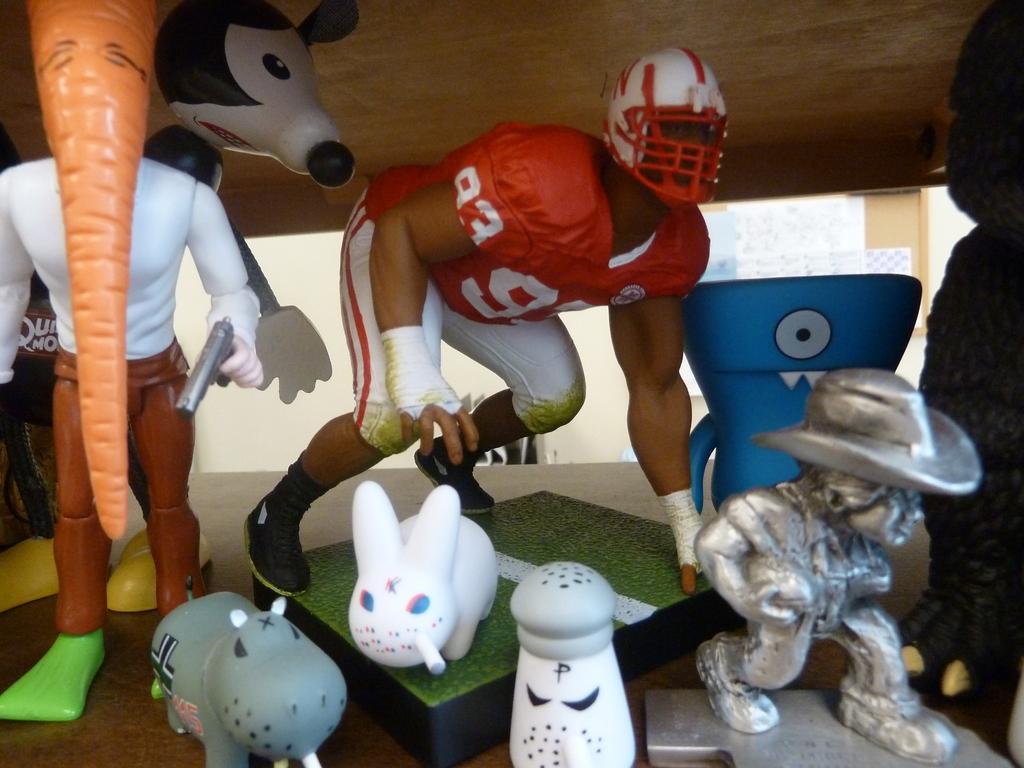In one or two sentences, can you explain what this image depicts? In the center of the image we can see a man bending he is wearing a helmet and there are blocks, toys, statues and a sculpture. 